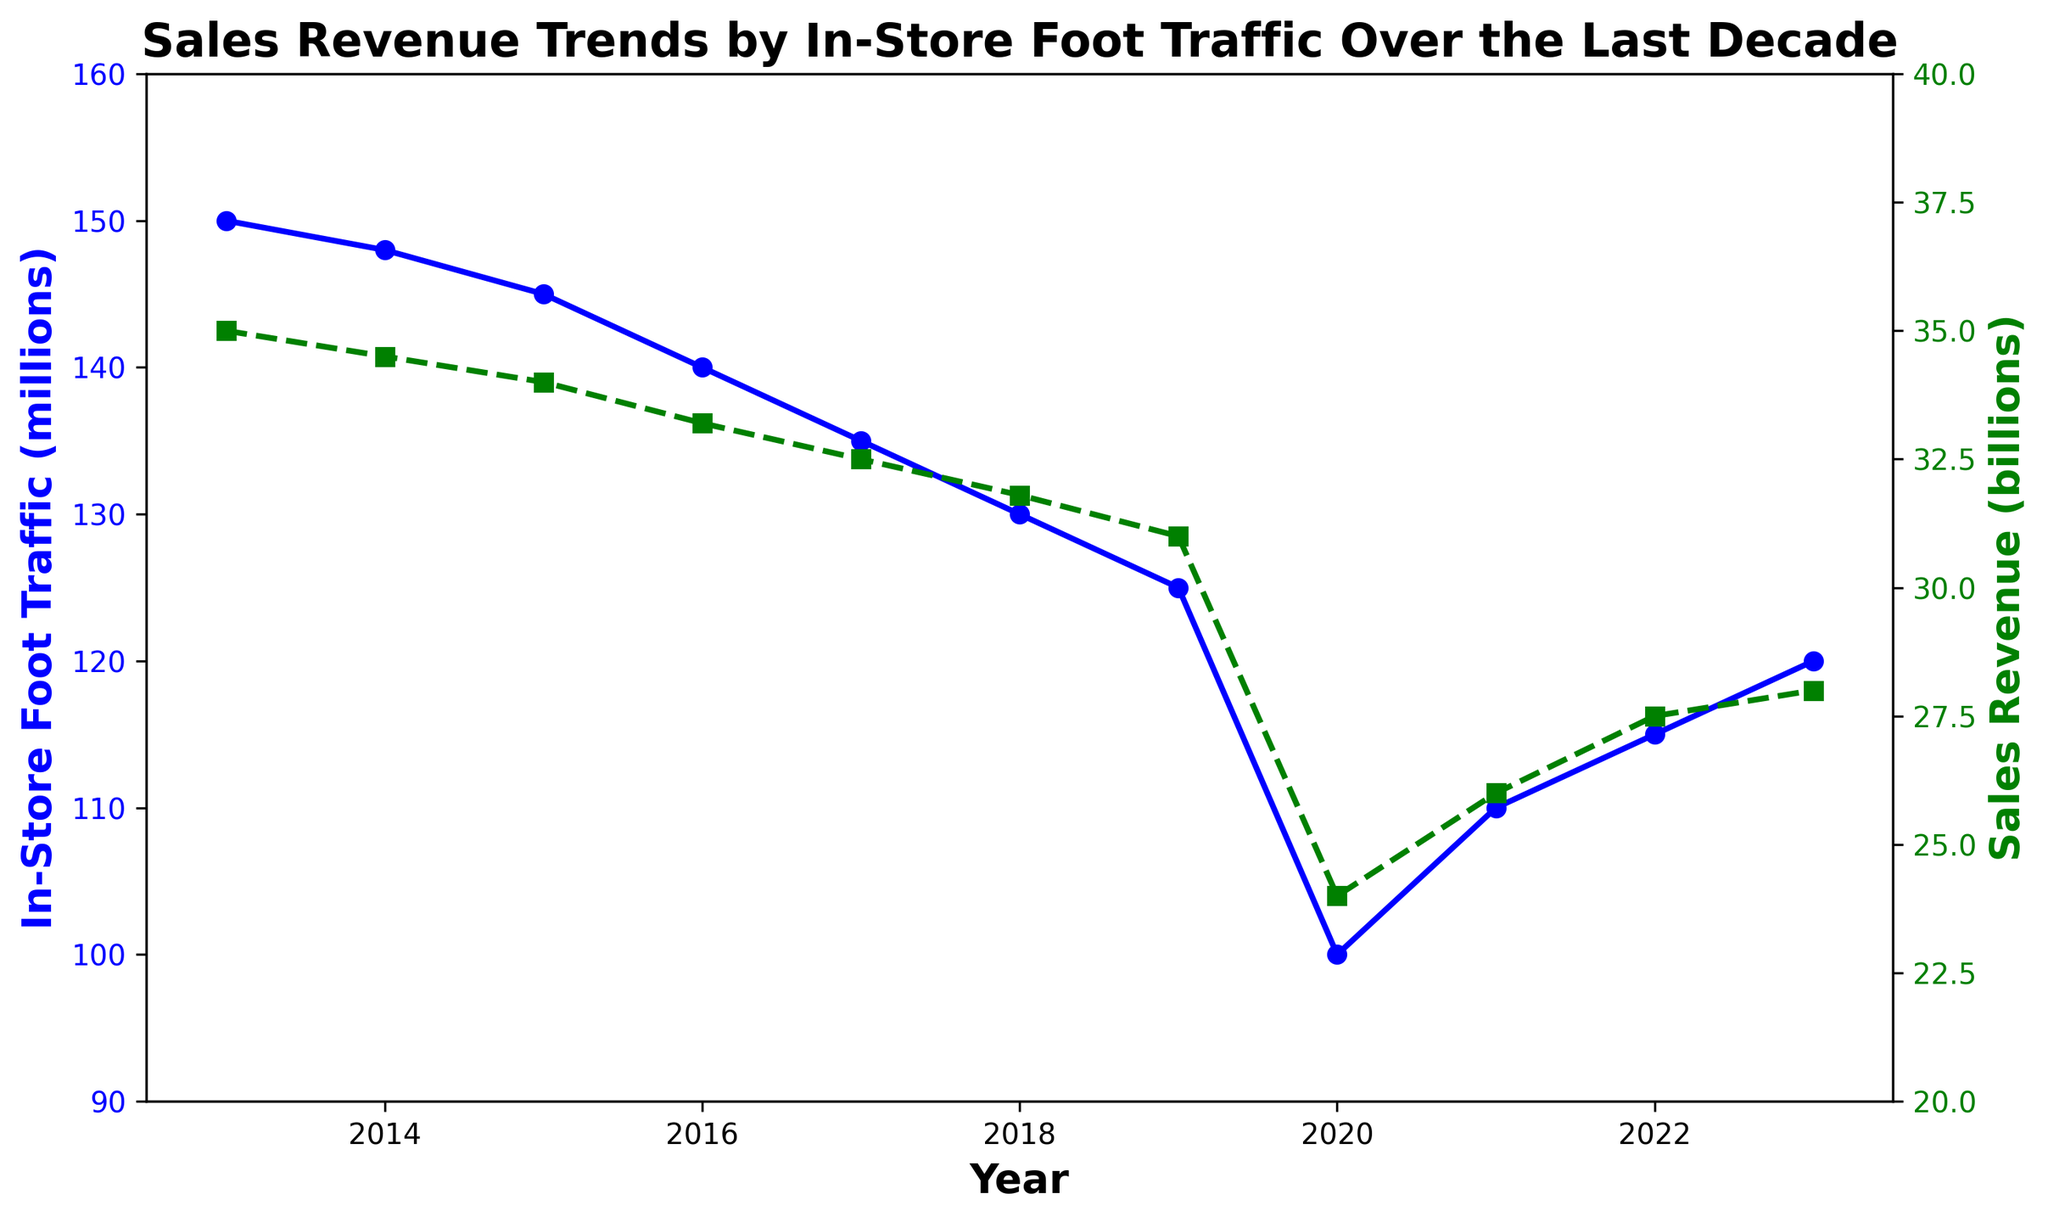What's the trend in in-store foot traffic from 2013 to 2023? From 2013 to 2023, the in-store foot traffic shows a general decline, starting at 150 million in 2013 and falling to 120 million in 2023. The trend indicates a decrease with some slight recovery in the last three years.
Answer: Decreasing with slight recovery Which year saw the lowest sales revenue and what was the value? We can observe that 2020 saw the lowest sales revenue, which was $24 billion. This is visually represented by the green line with the marker situated at the lowest point on the y-axis for sales revenue.
Answer: 2020, $24 billion How did the in-store foot traffic change between 2019 and 2020, and how did it relate to sales revenue in the same period? From 2019 to 2020, the in-store foot traffic dropped significantly from 125 million to 100 million. Similarly, sales revenue also decreased from $31 billion to $24 billion. This indicates a strong relationship between foot traffic and sales revenue.
Answer: In-store foot traffic decreased by 25 million, sales revenue decreased by $7 billion What is the average sales revenue from 2013 to 2023? Summing up the sales revenue for every year from 2013 to 2023: 35 + 34.5 + 34 + 33.2 + 32.5 + 31.8 + 31 + 24 + 26 + 27.5 + 28, and then dividing by the number of years (11), gives us: 337.5 / 11 ≈ 30.68 billion.
Answer: $30.68 billion Between which two consecutive years was the largest drop in sales revenue observed? By examining the dips in the green line, the largest drop in sales revenue occurred between 2019 and 2020. Sales revenue went from $31 billion in 2019 to $24 billion in 2020, which is a drop of $7 billion.
Answer: 2019 to 2020 How did sales revenue change from 2013 to 2018? Looking at the graph, sales revenue declined from $35 billion in 2013 to $31.8 billion in 2018. This is a gradual decline represented by the green line.
Answer: Decreased by $3.2 billion What is the difference in in-store foot traffic between the maximum and minimum values observed in the given years? The maximum value of in-store foot traffic is 150 million in 2013 and the minimum is 100 million in 2020. Therefore, the difference is 150 million - 100 million = 50 million.
Answer: 50 million What were the trends in in-store foot traffic and sales revenue in the last three years (2021-2023)? From 2021 to 2023, we can see that in-store foot traffic and sales revenue both show an upward trend. In-store foot traffic increased from 110 million in 2021 to 120 million in 2023, and sales revenue increased from $26 billion to $28 billion.
Answer: Both increased In which year did the in-store foot traffic start to recover after a continuous decline? The in-store foot traffic began recovering in 2021 after a continuous decline, as indicated by the blue line rising from 100 million in 2020 to 110 million in 2021.
Answer: 2021 